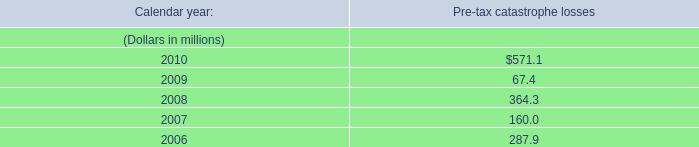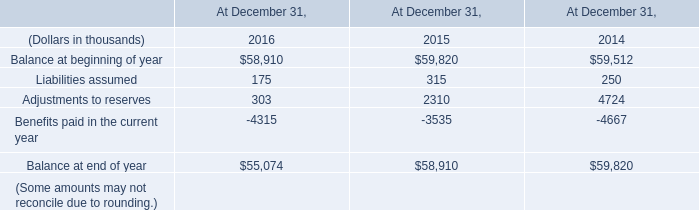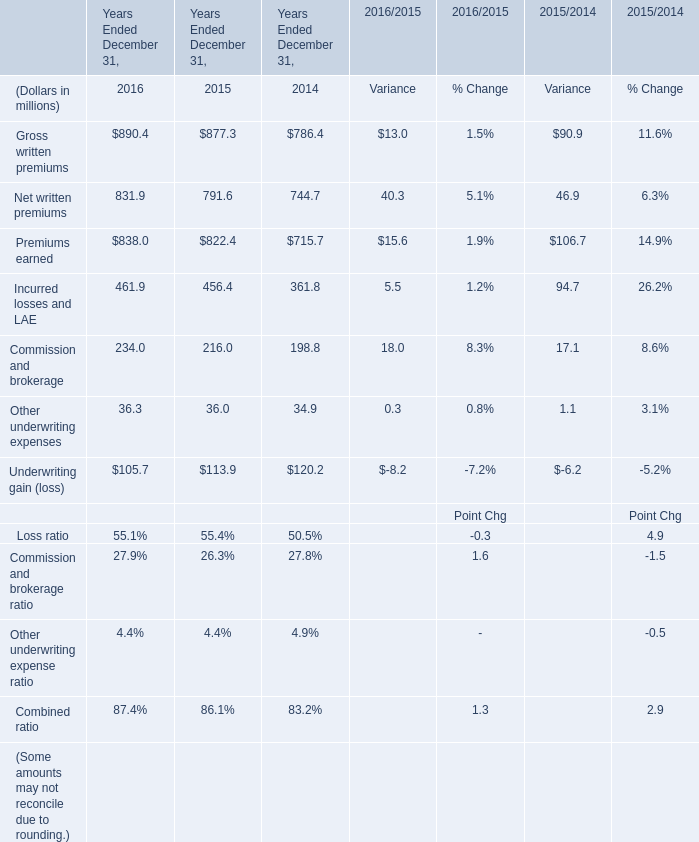what would be the net value , in millions of dollars , of investment gains in 2008 if all unrealized losses were realized? 
Computations: (695.8 - 310.4)
Answer: 385.4. 